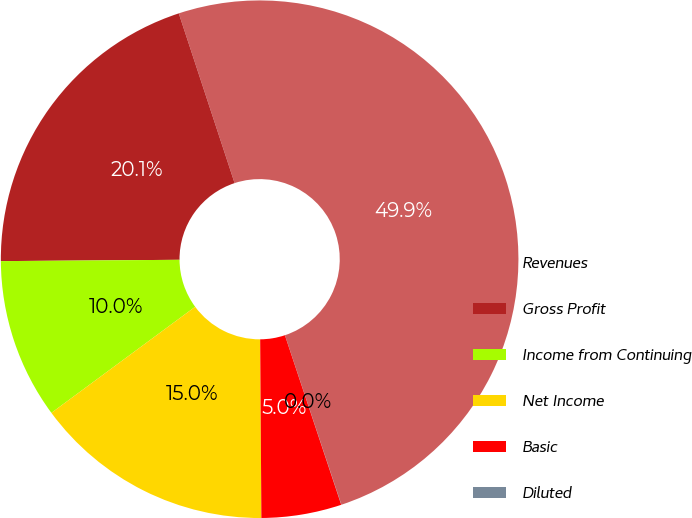<chart> <loc_0><loc_0><loc_500><loc_500><pie_chart><fcel>Revenues<fcel>Gross Profit<fcel>Income from Continuing<fcel>Net Income<fcel>Basic<fcel>Diluted<nl><fcel>49.94%<fcel>20.06%<fcel>10.0%<fcel>14.99%<fcel>5.0%<fcel>0.01%<nl></chart> 